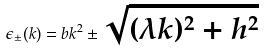Convert formula to latex. <formula><loc_0><loc_0><loc_500><loc_500>\epsilon _ { \pm } ( k ) = b k ^ { 2 } \pm \sqrt { ( \lambda k ) ^ { 2 } + h ^ { 2 } }</formula> 